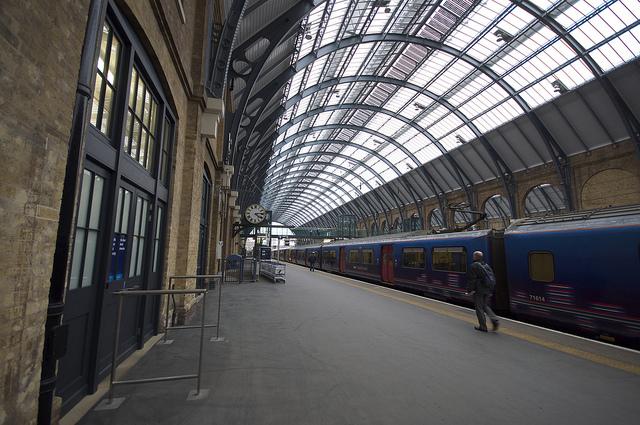Is the train platform crowded?
Give a very brief answer. No. Is the man running or walking?
Be succinct. Running. Can you see reflections in the floor?
Give a very brief answer. No. Is there a train in the depot?
Be succinct. Yes. Are these guard-railed areas not unlike the herding areas used for cows?
Give a very brief answer. Yes. 